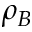Convert formula to latex. <formula><loc_0><loc_0><loc_500><loc_500>\rho _ { B }</formula> 